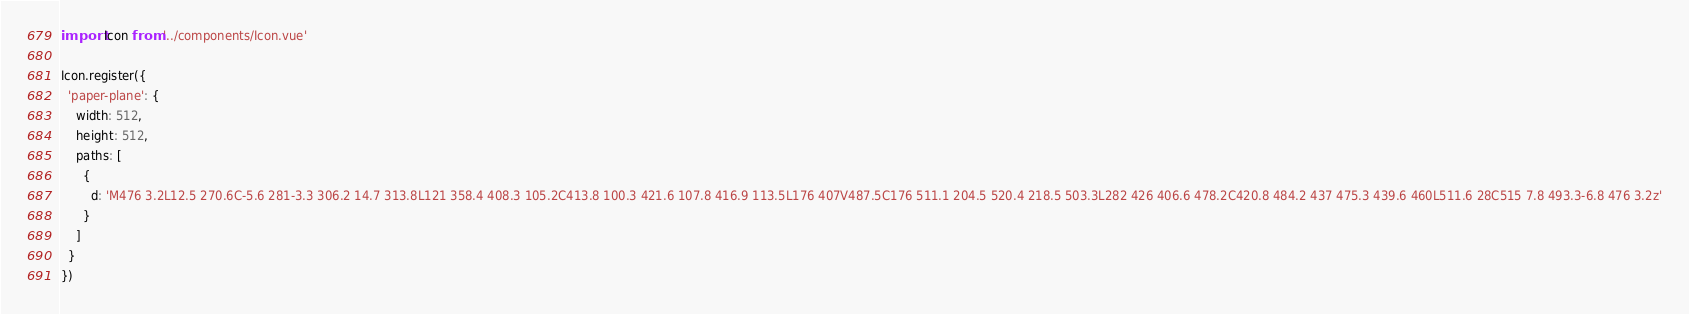Convert code to text. <code><loc_0><loc_0><loc_500><loc_500><_JavaScript_>import Icon from '../components/Icon.vue'

Icon.register({
  'paper-plane': {
    width: 512,
    height: 512,
    paths: [
      {
        d: 'M476 3.2L12.5 270.6C-5.6 281-3.3 306.2 14.7 313.8L121 358.4 408.3 105.2C413.8 100.3 421.6 107.8 416.9 113.5L176 407V487.5C176 511.1 204.5 520.4 218.5 503.3L282 426 406.6 478.2C420.8 484.2 437 475.3 439.6 460L511.6 28C515 7.8 493.3-6.8 476 3.2z'
      }
    ]
  }
})
</code> 